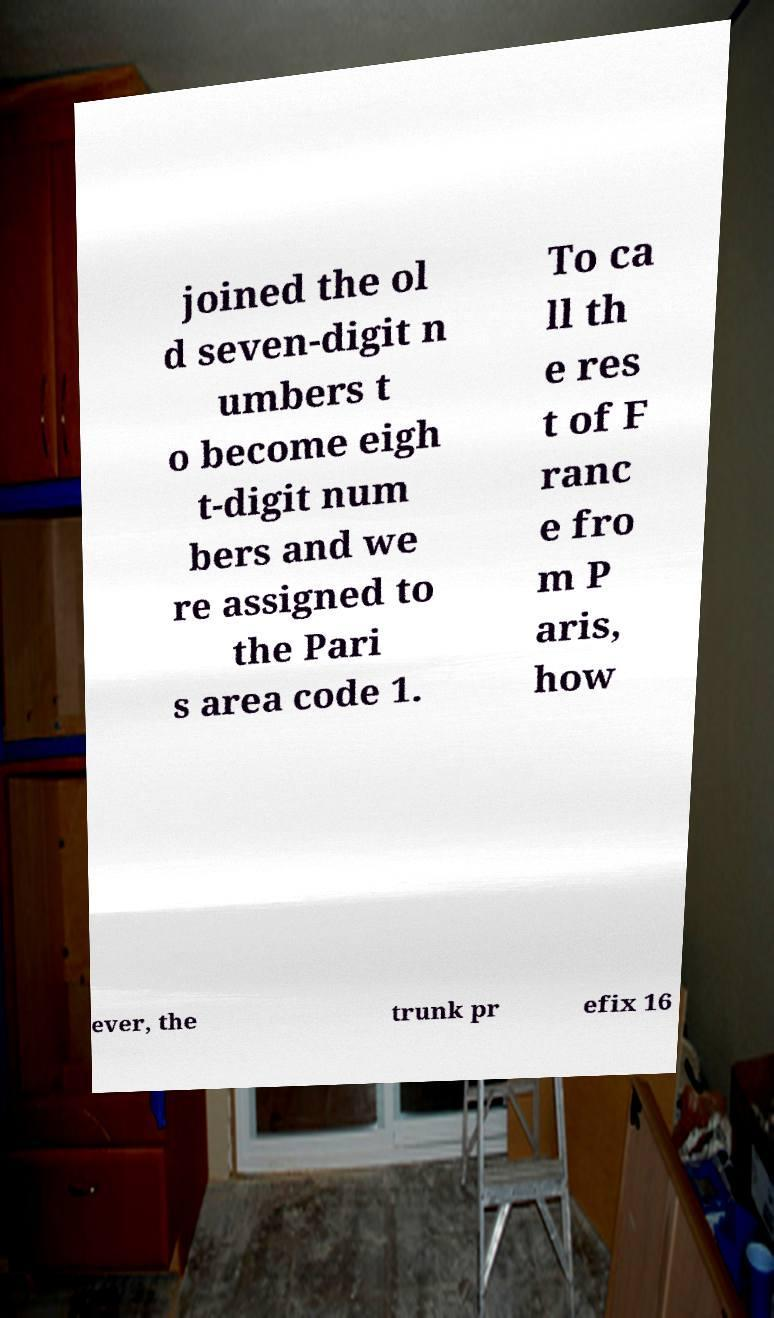I need the written content from this picture converted into text. Can you do that? joined the ol d seven-digit n umbers t o become eigh t-digit num bers and we re assigned to the Pari s area code 1. To ca ll th e res t of F ranc e fro m P aris, how ever, the trunk pr efix 16 